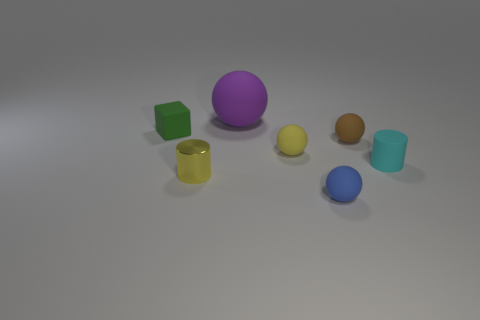Can you describe the lighting in this scene? The scene is softly lit, likely by a wide light source above, given the gentle shadows beneath each object. There's minimal contrast, suggesting a diffuse, ambient light setup. 